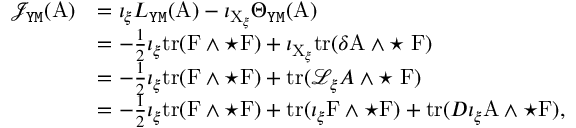<formula> <loc_0><loc_0><loc_500><loc_500>\begin{array} { r l } { \mathcal { J } _ { Y M } ( A ) } & { = \iota _ { \xi } L _ { Y M } ( A ) - \iota _ { X _ { \xi } } \Theta _ { Y M } ( A ) } \\ & { = - \frac { 1 } { 2 } \iota _ { \xi } t r ( F \wedge ^ { * } F ) + \iota _ { X _ { \xi } } t r ( \delta A \wedge ^ { * } \, F ) } \\ & { = - \frac { 1 } { 2 } \iota _ { \xi } t r ( F \wedge ^ { * } F ) + t r ( \mathcal { L } _ { \xi } A \wedge ^ { * } \, F ) } \\ & { = - \frac { 1 } { 2 } \iota _ { \xi } t r ( F \wedge ^ { * } F ) + t r ( \iota _ { \xi } F \wedge ^ { * } F ) + t r ( D \iota _ { \xi } A \wedge ^ { * } F ) , } \end{array}</formula> 